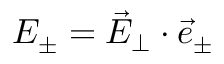<formula> <loc_0><loc_0><loc_500><loc_500>E _ { \pm } = \vec { E } _ { \perp } \cdot \vec { e } _ { \pm }</formula> 